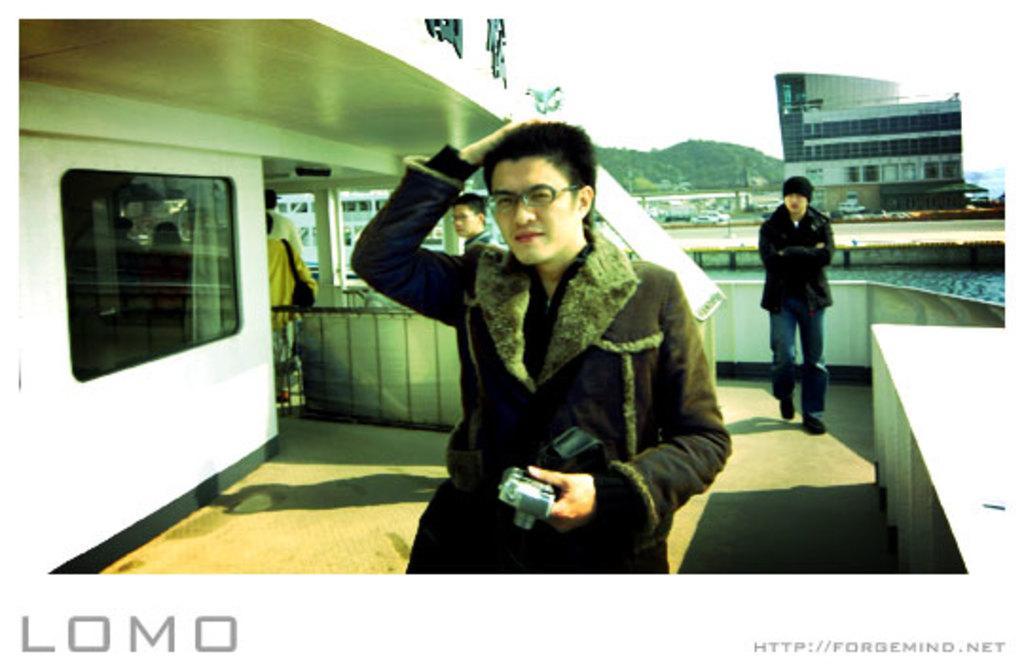How would you summarize this image in a sentence or two? In the middle a man is walking he wore a coat, spectacles. In the right side there are buildings. 